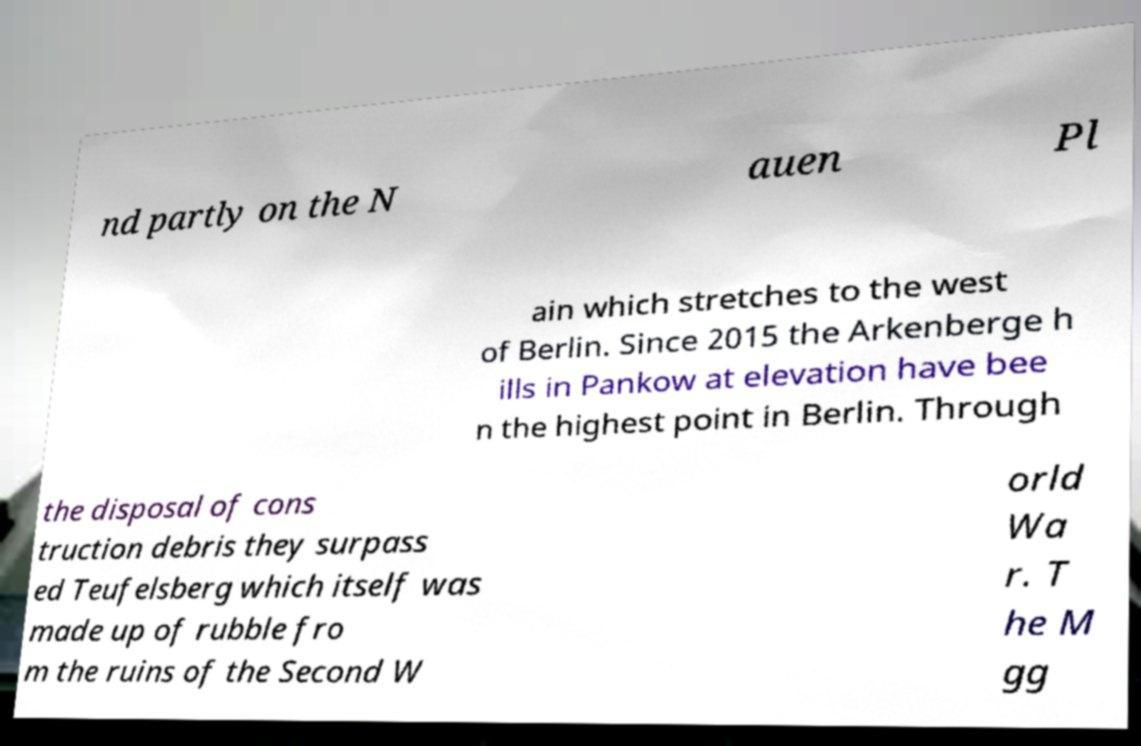For documentation purposes, I need the text within this image transcribed. Could you provide that? nd partly on the N auen Pl ain which stretches to the west of Berlin. Since 2015 the Arkenberge h ills in Pankow at elevation have bee n the highest point in Berlin. Through the disposal of cons truction debris they surpass ed Teufelsberg which itself was made up of rubble fro m the ruins of the Second W orld Wa r. T he M gg 